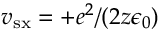<formula> <loc_0><loc_0><loc_500><loc_500>v _ { s x } = + e ^ { 2 } / ( 2 z \epsilon _ { 0 } )</formula> 